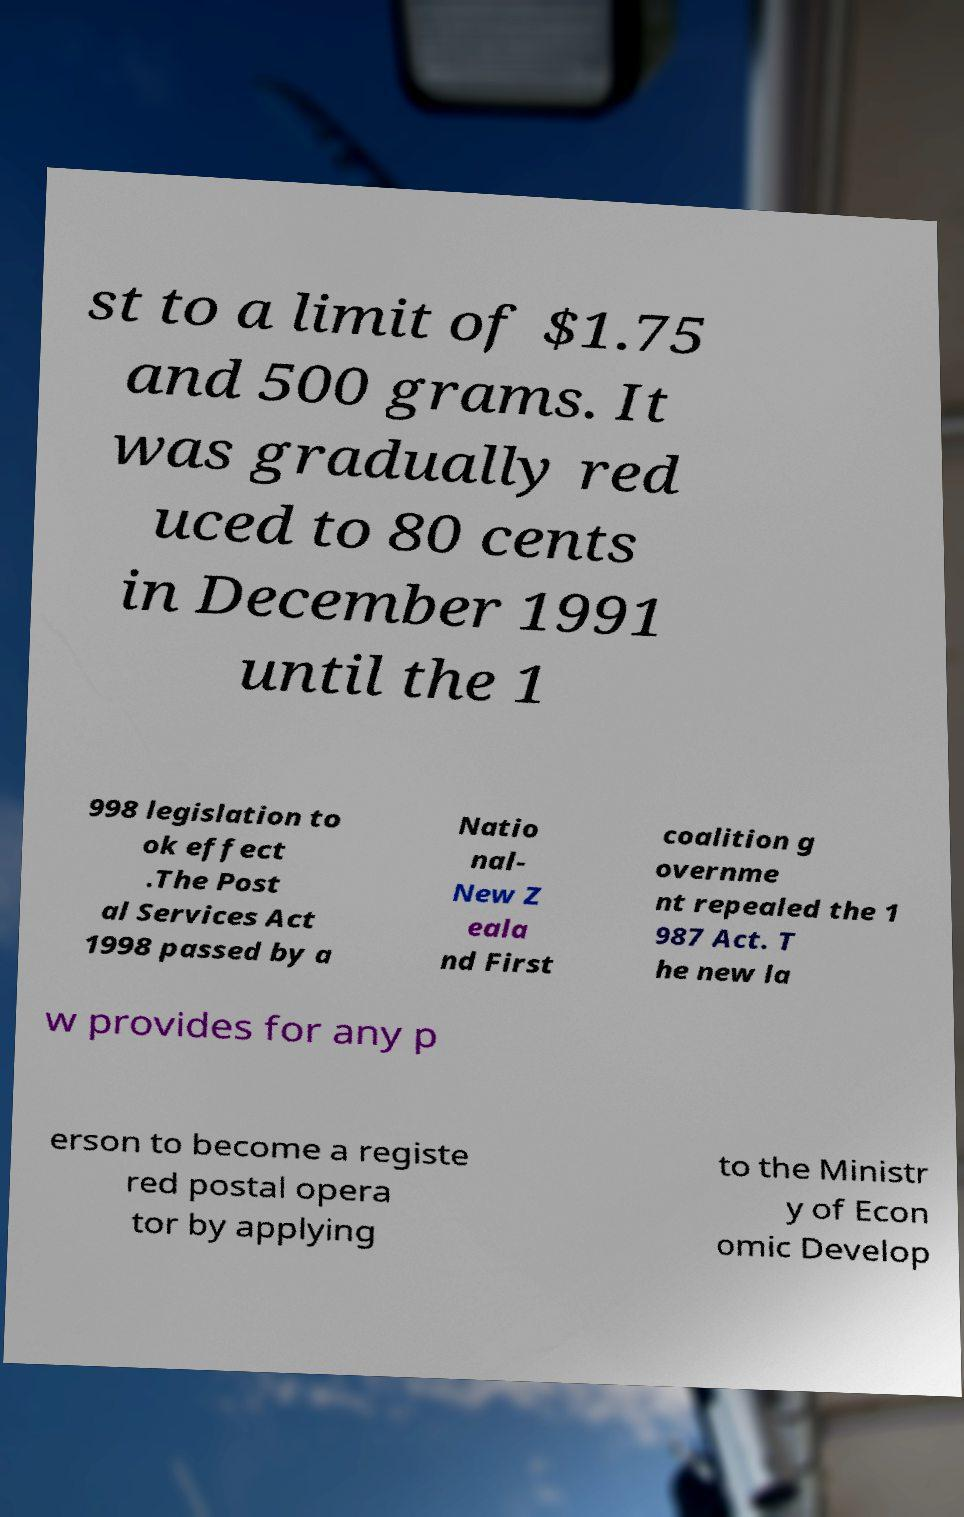Please read and relay the text visible in this image. What does it say? st to a limit of $1.75 and 500 grams. It was gradually red uced to 80 cents in December 1991 until the 1 998 legislation to ok effect .The Post al Services Act 1998 passed by a Natio nal- New Z eala nd First coalition g overnme nt repealed the 1 987 Act. T he new la w provides for any p erson to become a registe red postal opera tor by applying to the Ministr y of Econ omic Develop 